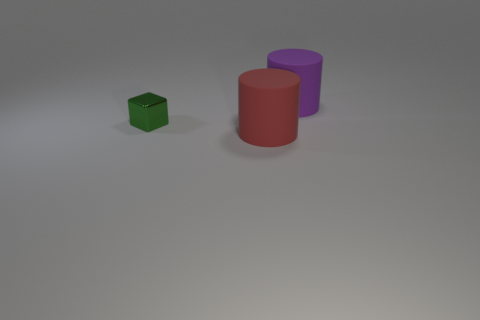Add 1 blue metallic blocks. How many objects exist? 4 Subtract all cylinders. How many objects are left? 1 Add 3 small blue things. How many small blue things exist? 3 Subtract 0 blue balls. How many objects are left? 3 Subtract all big gray rubber cylinders. Subtract all red matte objects. How many objects are left? 2 Add 2 purple matte cylinders. How many purple matte cylinders are left? 3 